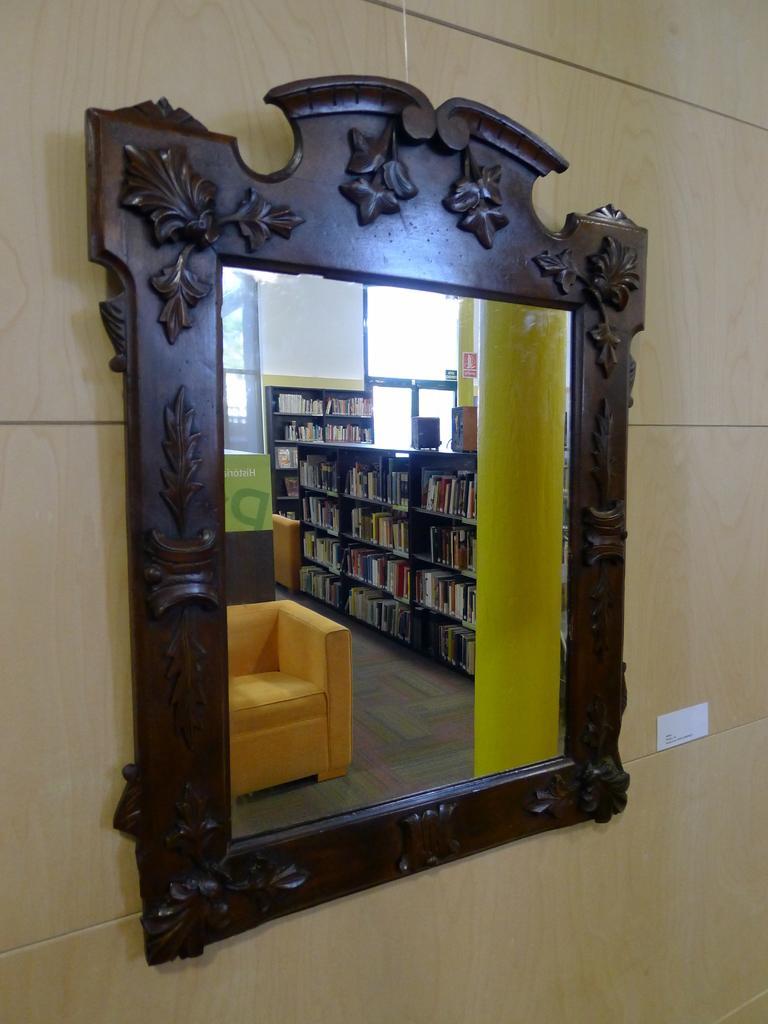Please provide a concise description of this image. In this image we can see a mirror on the ground. In the background, we can see sofa placed on the ground, a group of books placed in racks, speakers and windows. 